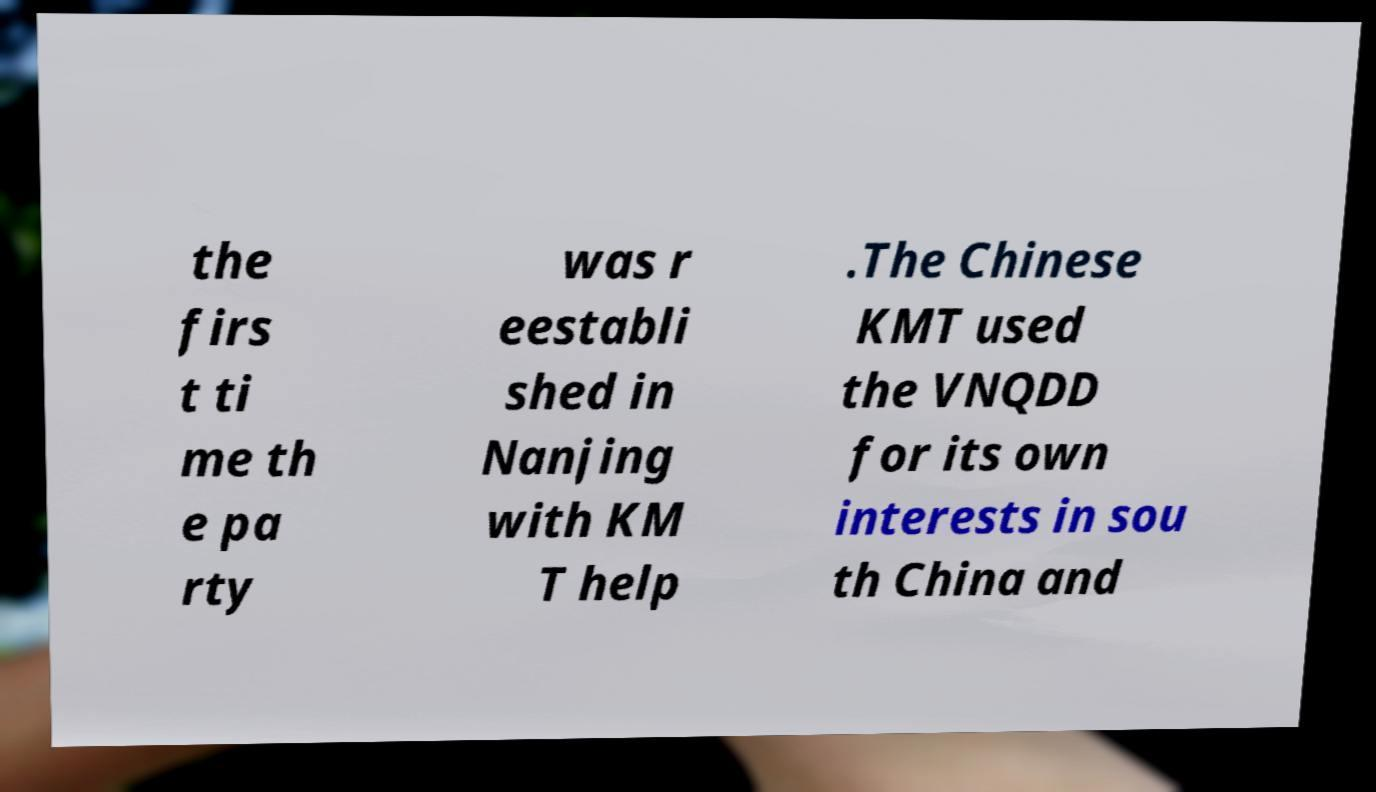Can you read and provide the text displayed in the image?This photo seems to have some interesting text. Can you extract and type it out for me? the firs t ti me th e pa rty was r eestabli shed in Nanjing with KM T help .The Chinese KMT used the VNQDD for its own interests in sou th China and 